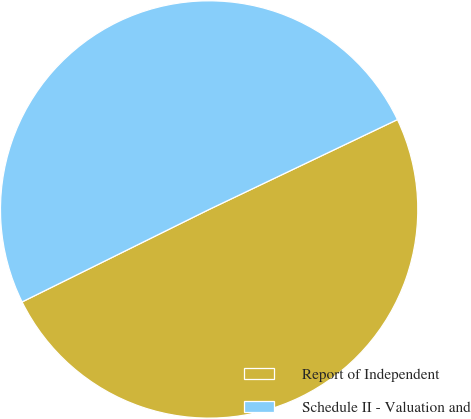<chart> <loc_0><loc_0><loc_500><loc_500><pie_chart><fcel>Report of Independent<fcel>Schedule II - Valuation and<nl><fcel>49.78%<fcel>50.22%<nl></chart> 